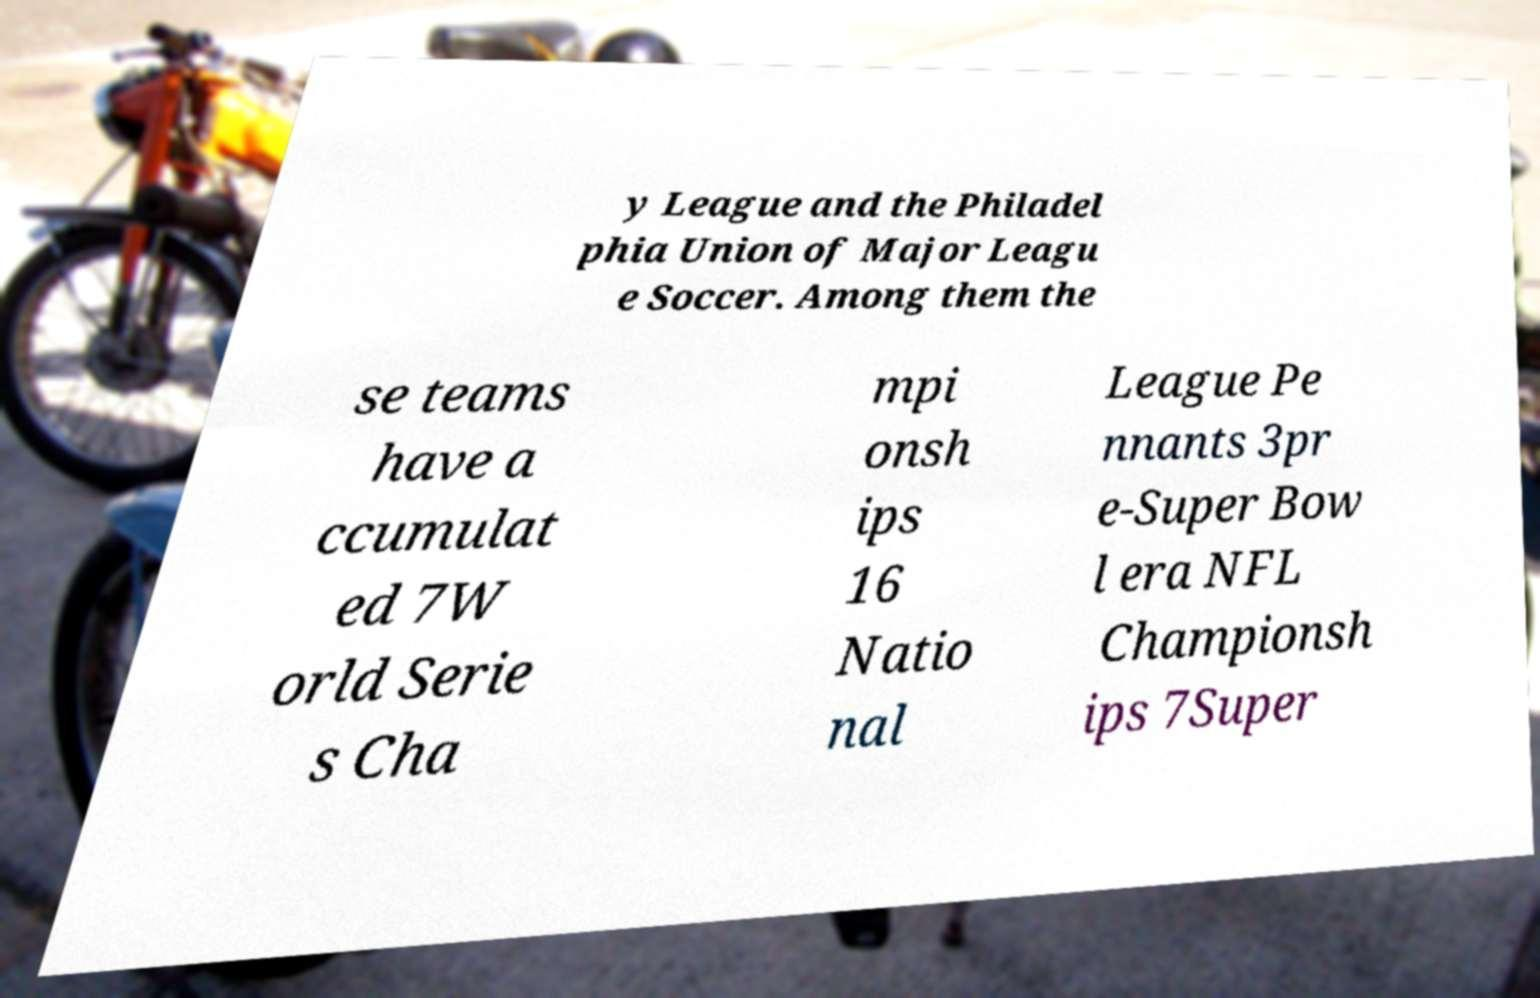Could you assist in decoding the text presented in this image and type it out clearly? y League and the Philadel phia Union of Major Leagu e Soccer. Among them the se teams have a ccumulat ed 7W orld Serie s Cha mpi onsh ips 16 Natio nal League Pe nnants 3pr e-Super Bow l era NFL Championsh ips 7Super 